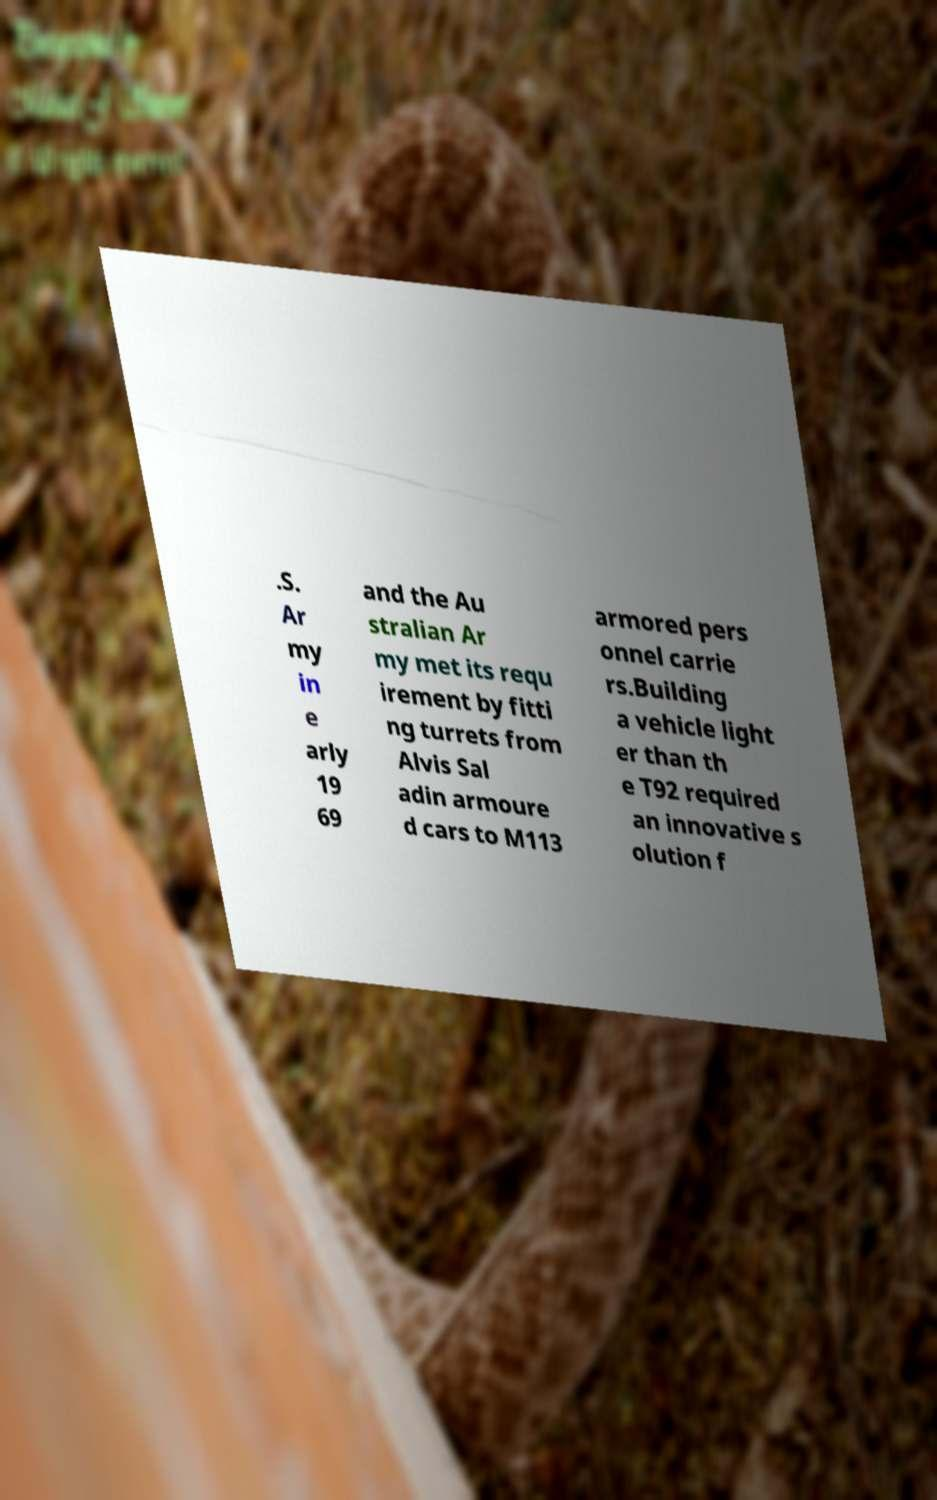What messages or text are displayed in this image? I need them in a readable, typed format. .S. Ar my in e arly 19 69 and the Au stralian Ar my met its requ irement by fitti ng turrets from Alvis Sal adin armoure d cars to M113 armored pers onnel carrie rs.Building a vehicle light er than th e T92 required an innovative s olution f 